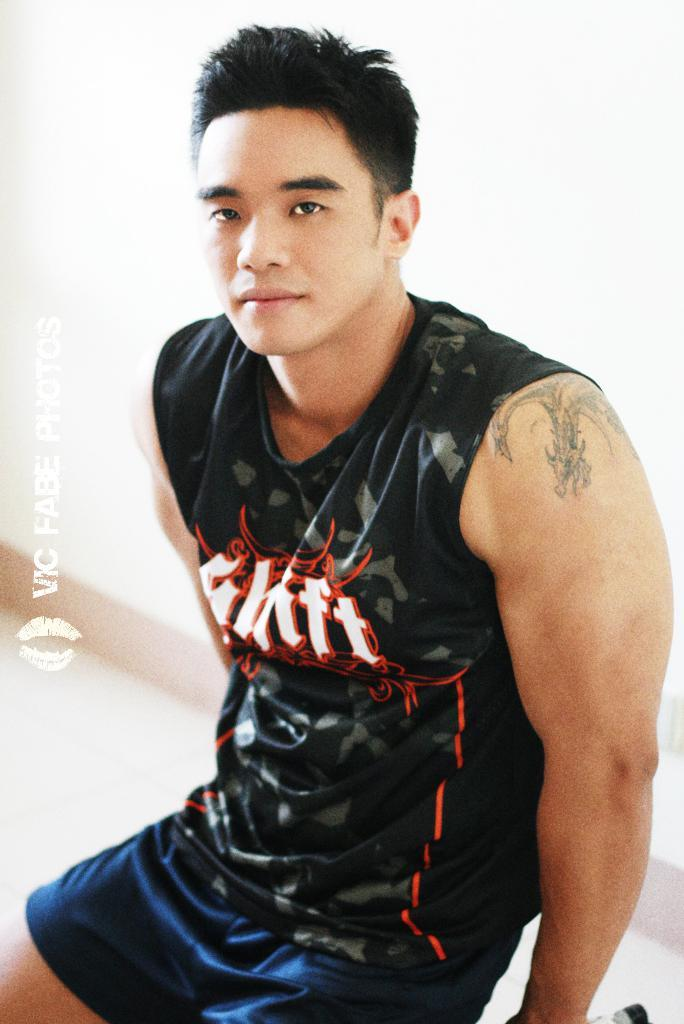<image>
Share a concise interpretation of the image provided. a muscle man in a shirt that reads Shift on it 